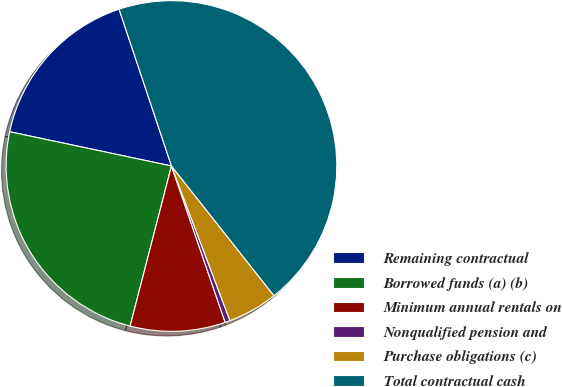<chart> <loc_0><loc_0><loc_500><loc_500><pie_chart><fcel>Remaining contractual<fcel>Borrowed funds (a) (b)<fcel>Minimum annual rentals on<fcel>Nonqualified pension and<fcel>Purchase obligations (c)<fcel>Total contractual cash<nl><fcel>16.55%<fcel>24.3%<fcel>9.29%<fcel>0.49%<fcel>4.89%<fcel>44.49%<nl></chart> 